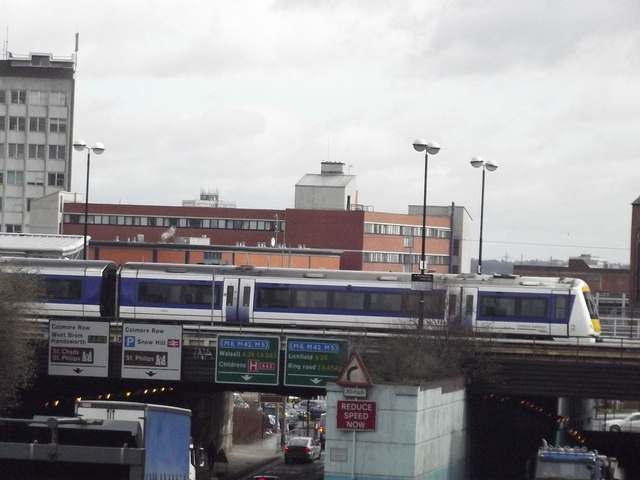Describe the objects in this image and their specific colors. I can see train in white, gray, darkgray, black, and navy tones, truck in white, gray, darkgray, and blue tones, truck in white, gray, black, and darkblue tones, car in white, black, gray, darkgray, and lightgray tones, and car in white, darkgray, gray, black, and lightgray tones in this image. 